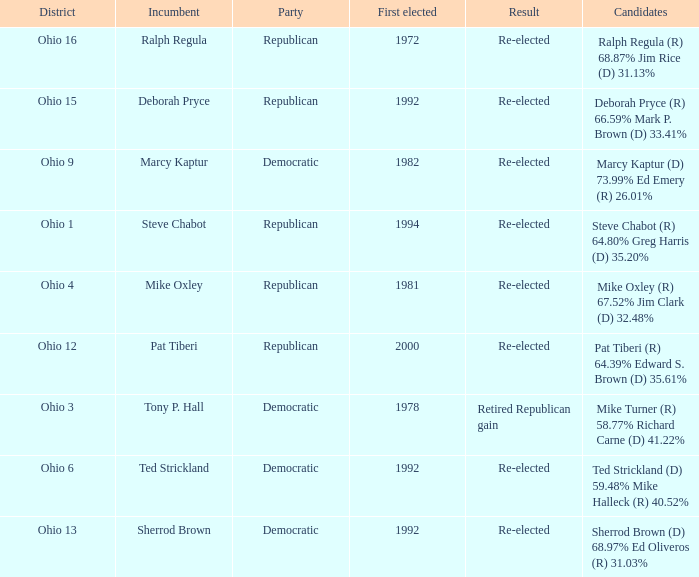In what district was the incumbent Steve Chabot?  Ohio 1. 